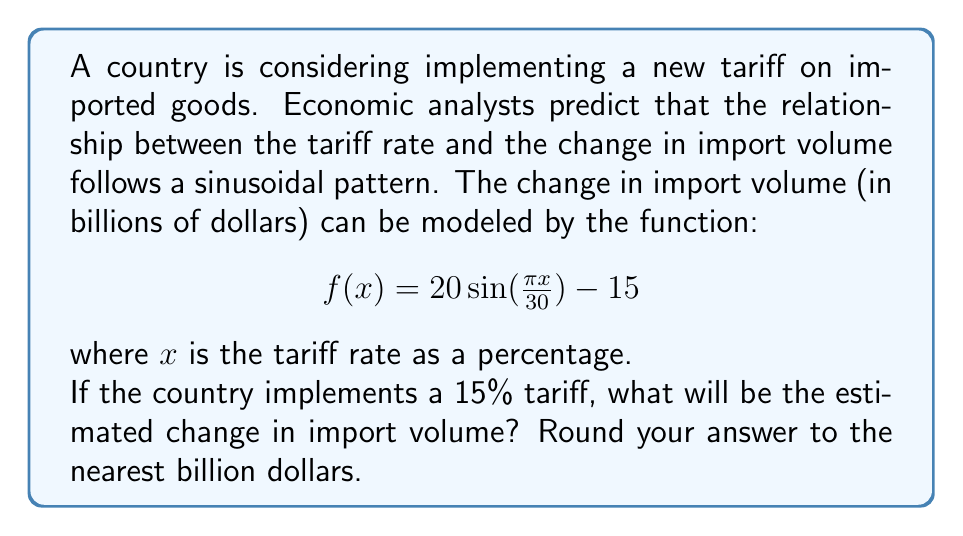Provide a solution to this math problem. To solve this problem, we need to follow these steps:

1) We are given the function:
   $$f(x) = 20 \sin(\frac{\pi x}{30}) - 15$$

2) We need to find $f(15)$, as the tariff rate is 15%.

3) Let's substitute $x = 15$ into the function:
   $$f(15) = 20 \sin(\frac{\pi \cdot 15}{30}) - 15$$

4) Simplify the fraction inside the sine function:
   $$f(15) = 20 \sin(\frac{\pi}{2}) - 15$$

5) Recall that $\sin(\frac{\pi}{2}) = 1$

6) Now we can calculate:
   $$f(15) = 20 \cdot 1 - 15 = 20 - 15 = 5$$

7) The result is 5 billion dollars.

Therefore, with a 15% tariff, the estimated change in import volume is an increase of 5 billion dollars.
Answer: $5 billion 